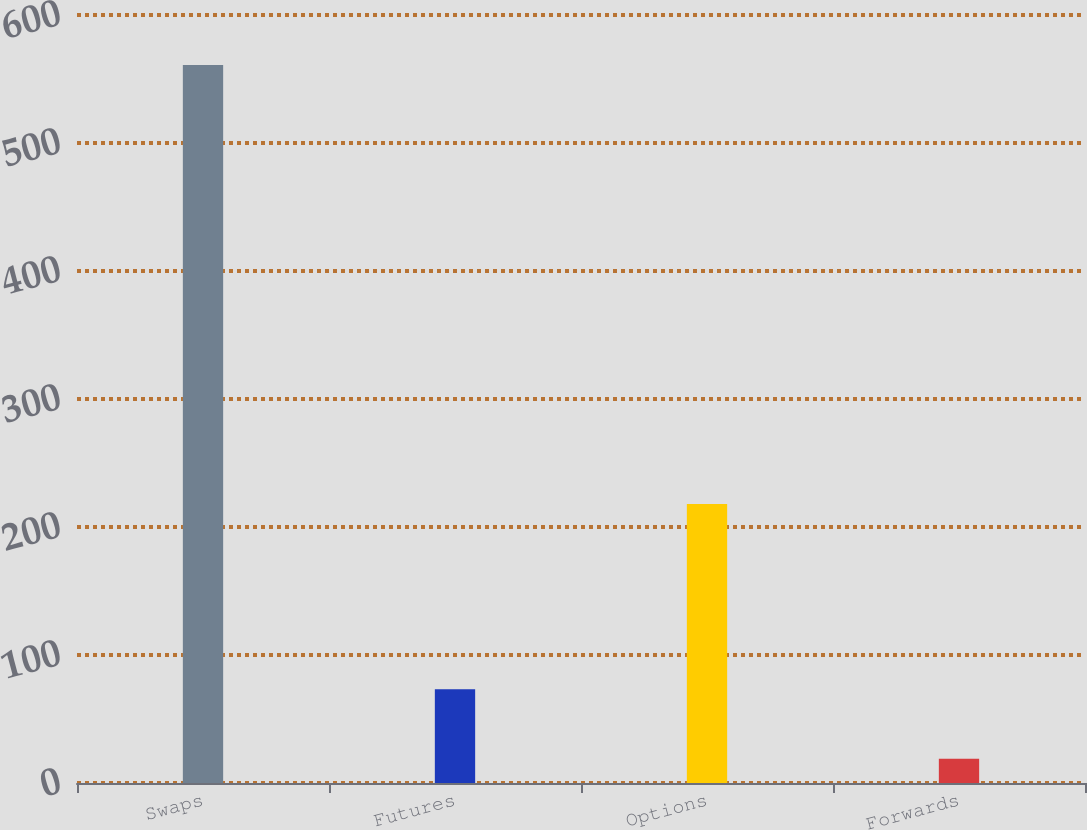<chart> <loc_0><loc_0><loc_500><loc_500><bar_chart><fcel>Swaps<fcel>Futures<fcel>Options<fcel>Forwards<nl><fcel>561<fcel>73.2<fcel>218<fcel>19<nl></chart> 